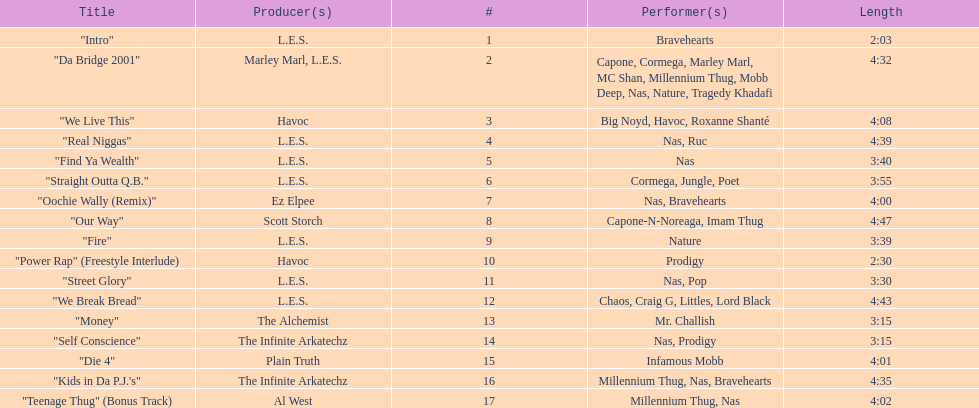What song was performed before "fire"? "Our Way". 